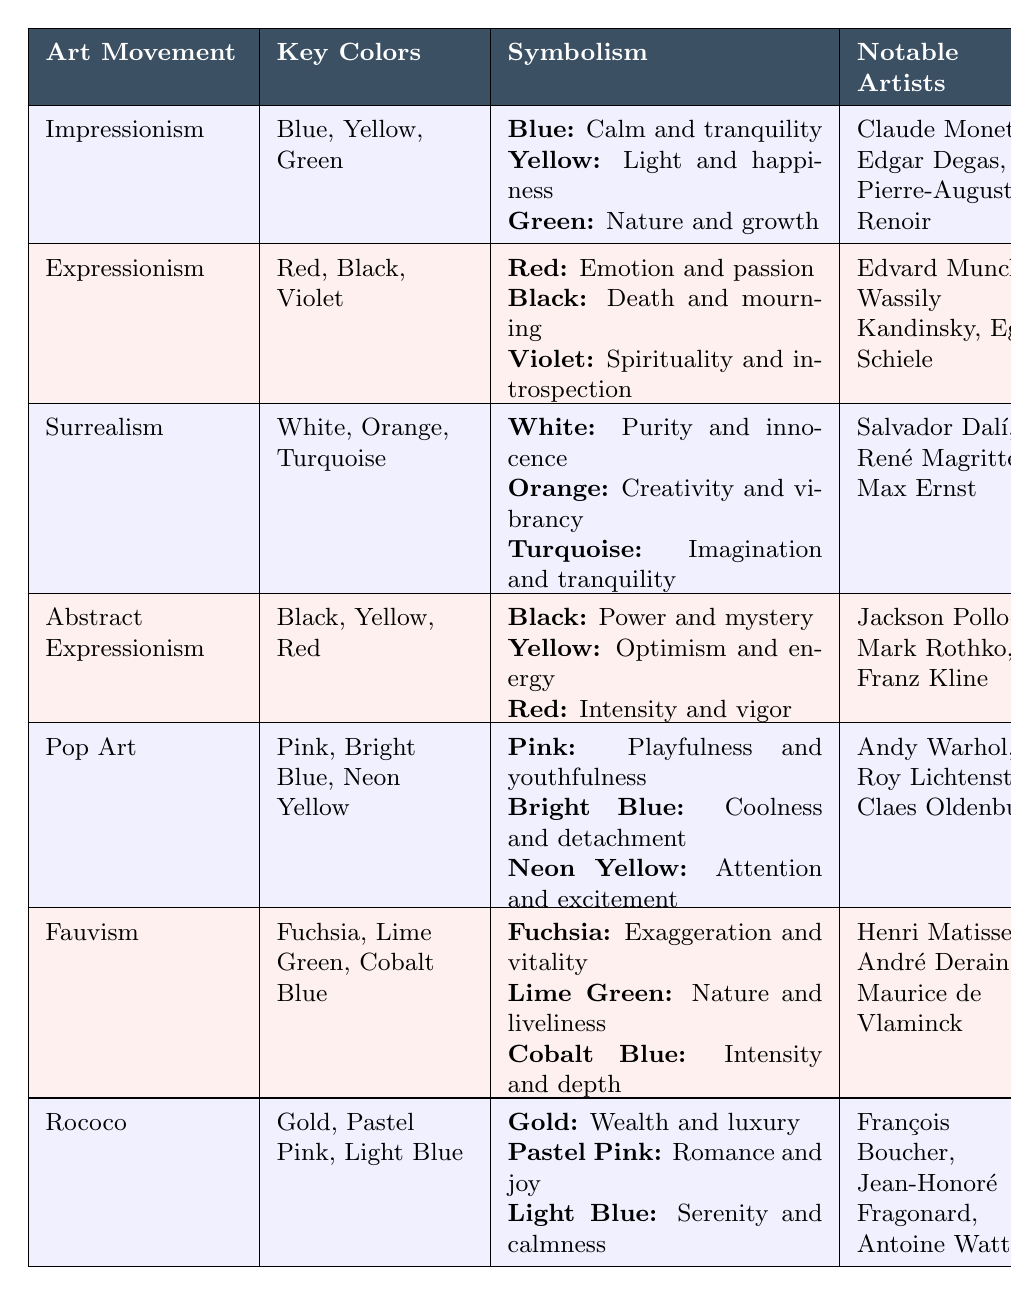What are the key colors used in Expressionism? From the table, the key colors listed under the Expressionism art movement are Red, Black, and Violet.
Answer: Red, Black, Violet Which artist is associated with the notable artwork "The Persistence of Memory"? The table indicates that Salvador Dalí is the notable artist associated with the artwork "The Persistence of Memory" under the Surrealism movement.
Answer: Salvador Dalí Is Yellow used in both Impressionism and Abstract Expressionism? According to the table, Yellow appears as a key color in both the Impressionism and Abstract Expressionism movements. Therefore, the statement is true.
Answer: Yes Which art movement symbolizes creativity and vibrancy with the color Orange? The color Orange symbolizes creativity and vibrancy in the Surrealism art movement, as specified in the table.
Answer: Surrealism What is the difference between the key colors of Fauvism and Rococo movements? The key colors for Fauvism are Fuchsia, Lime Green, and Cobalt Blue, while for Rococo they are Gold, Pastel Pink, and Light Blue. Thus, the difference is the specific colors listed for each movement.
Answer: Fuchsia, Lime Green, Cobalt Blue vs. Gold, Pastel Pink, Light Blue Name the notable artists associated with the Pop Art movement. The table includes Andy Warhol, Roy Lichtenstein, and Claes Oldenburg as notable artists associated with the Pop Art movement.
Answer: Andy Warhol, Roy Lichtenstein, Claes Oldenburg If we consider the number of colors associated with each art movement, how many total unique colors are used across all movements? The total unique colors mentioned across all movements are: Blue, Yellow, Green, Red, Black, Violet, White, Orange, Turquoise, Pink, Bright Blue, Neon Yellow, Fuchsia, Lime Green, Cobalt Blue, Gold, Pastel Pink, and Light Blue. Counting these gives a total of 17 unique colors.
Answer: 17 Which art movement primarily uses the color Gold to symbolize wealth and luxury? The table attributes the color Gold to the Rococo movement, indicating it symbolizes wealth and luxury.
Answer: Rococo Does the color Black have the same symbolism in both Expressionism and Abstract Expressionism? In Expressionism, Black symbolizes death and mourning, whereas in Abstract Expressionism it symbolizes power and mystery. Thus, the symbolism differs between the two movements.
Answer: No Which two movements use the color Yellow and what do they symbolize? Impressionism uses Yellow to symbolize light and happiness, while Abstract Expressionism uses it to symbolize optimism and energy.
Answer: Impressionism (light and happiness), Abstract Expressionism (optimism and energy) 